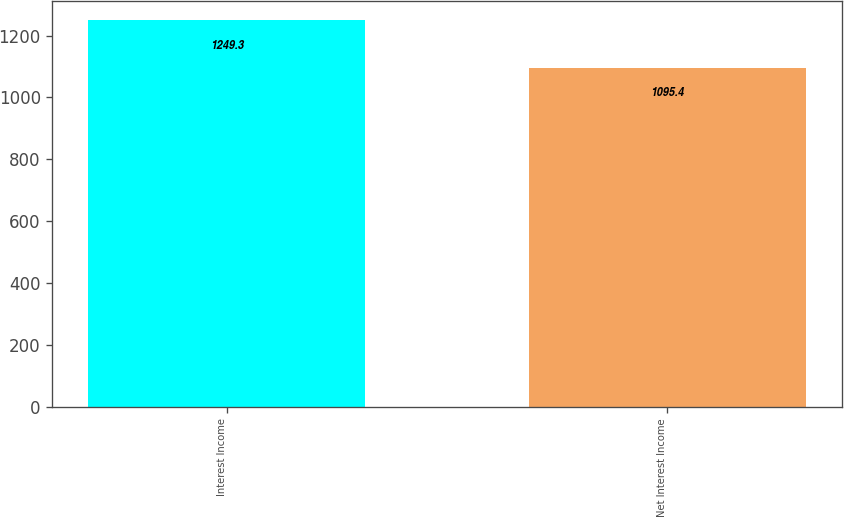Convert chart to OTSL. <chart><loc_0><loc_0><loc_500><loc_500><bar_chart><fcel>Interest Income<fcel>Net Interest Income<nl><fcel>1249.3<fcel>1095.4<nl></chart> 